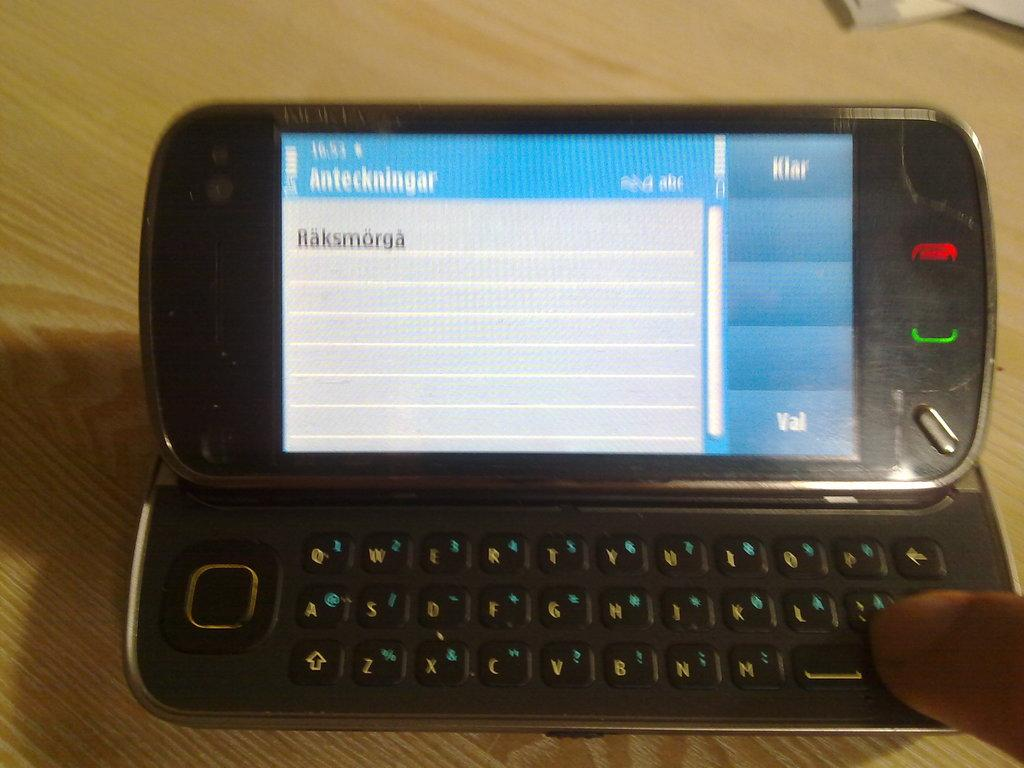What electronic device is visible in the image? There is a mobile phone in the image. What type of surface is the mobile phone placed on? The mobile phone is on a wooden surface. Can you describe any interaction with the mobile phone in the image? There is a finger of a person on the mobile phone. How many centimeters is the hour hand of the clock in the image? There is no clock or hour hand present in the image; it only features a mobile phone with a finger on it. 